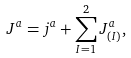Convert formula to latex. <formula><loc_0><loc_0><loc_500><loc_500>J ^ { a } = j ^ { a } + \sum _ { I = 1 } ^ { 2 } J _ { ( I ) } ^ { a } ,</formula> 